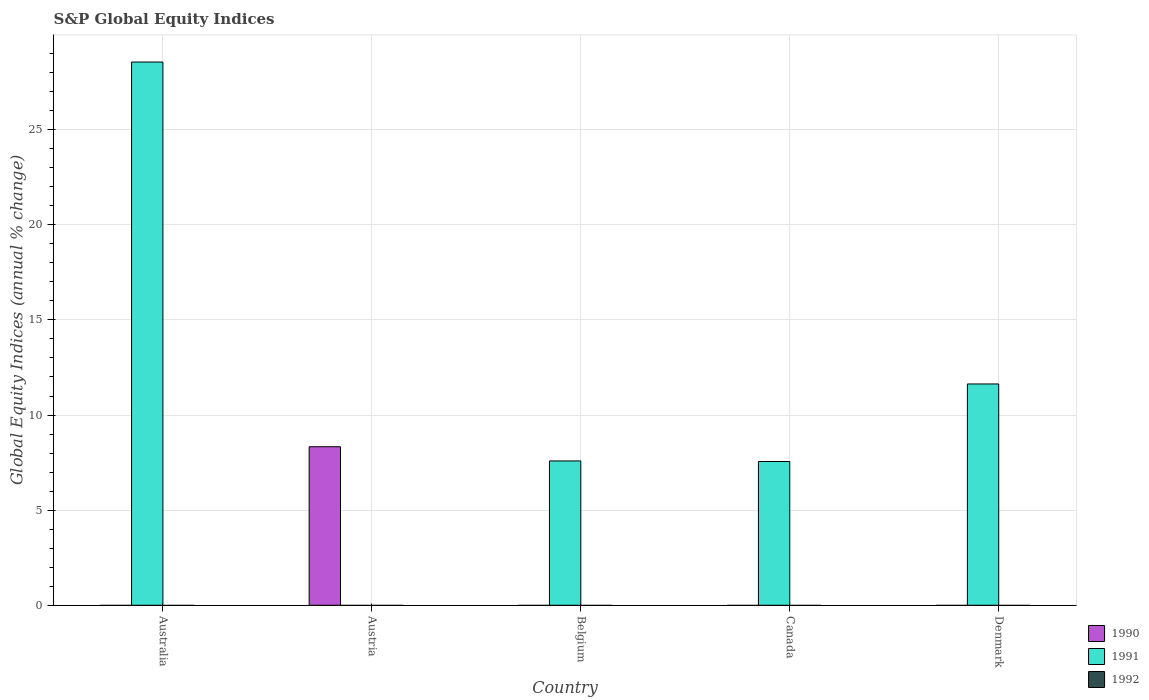How many bars are there on the 5th tick from the left?
Make the answer very short. 1. How many bars are there on the 2nd tick from the right?
Make the answer very short. 1. What is the global equity indices in 1990 in Canada?
Offer a terse response. 0. Across all countries, what is the maximum global equity indices in 1991?
Your response must be concise. 28.56. In which country was the global equity indices in 1990 maximum?
Offer a very short reply. Austria. What is the total global equity indices in 1990 in the graph?
Make the answer very short. 8.33. What is the difference between the global equity indices in 1991 in Canada and that in Denmark?
Your response must be concise. -4.08. What is the difference between the global equity indices in 1990 in Canada and the global equity indices in 1991 in Australia?
Your response must be concise. -28.56. What is the average global equity indices in 1991 per country?
Offer a very short reply. 11.07. What is the ratio of the global equity indices in 1991 in Australia to that in Belgium?
Keep it short and to the point. 3.76. Is the global equity indices in 1991 in Canada less than that in Denmark?
Offer a very short reply. Yes. What is the difference between the highest and the second highest global equity indices in 1991?
Your answer should be compact. -16.92. What is the difference between the highest and the lowest global equity indices in 1991?
Provide a short and direct response. 28.56. How many bars are there?
Keep it short and to the point. 5. How many countries are there in the graph?
Your answer should be very brief. 5. Are the values on the major ticks of Y-axis written in scientific E-notation?
Offer a very short reply. No. Does the graph contain any zero values?
Offer a terse response. Yes. Does the graph contain grids?
Offer a terse response. Yes. Where does the legend appear in the graph?
Provide a succinct answer. Bottom right. How many legend labels are there?
Give a very brief answer. 3. How are the legend labels stacked?
Your answer should be compact. Vertical. What is the title of the graph?
Keep it short and to the point. S&P Global Equity Indices. What is the label or title of the Y-axis?
Your answer should be very brief. Global Equity Indices (annual % change). What is the Global Equity Indices (annual % change) in 1991 in Australia?
Your answer should be compact. 28.56. What is the Global Equity Indices (annual % change) in 1990 in Austria?
Ensure brevity in your answer.  8.33. What is the Global Equity Indices (annual % change) in 1991 in Belgium?
Ensure brevity in your answer.  7.59. What is the Global Equity Indices (annual % change) in 1990 in Canada?
Offer a terse response. 0. What is the Global Equity Indices (annual % change) of 1991 in Canada?
Ensure brevity in your answer.  7.56. What is the Global Equity Indices (annual % change) in 1990 in Denmark?
Provide a short and direct response. 0. What is the Global Equity Indices (annual % change) in 1991 in Denmark?
Provide a short and direct response. 11.63. What is the Global Equity Indices (annual % change) in 1992 in Denmark?
Keep it short and to the point. 0. Across all countries, what is the maximum Global Equity Indices (annual % change) of 1990?
Offer a terse response. 8.33. Across all countries, what is the maximum Global Equity Indices (annual % change) in 1991?
Offer a terse response. 28.56. What is the total Global Equity Indices (annual % change) in 1990 in the graph?
Make the answer very short. 8.33. What is the total Global Equity Indices (annual % change) in 1991 in the graph?
Keep it short and to the point. 55.33. What is the difference between the Global Equity Indices (annual % change) of 1991 in Australia and that in Belgium?
Your answer should be compact. 20.97. What is the difference between the Global Equity Indices (annual % change) in 1991 in Australia and that in Canada?
Offer a terse response. 21. What is the difference between the Global Equity Indices (annual % change) in 1991 in Australia and that in Denmark?
Your answer should be very brief. 16.92. What is the difference between the Global Equity Indices (annual % change) of 1991 in Belgium and that in Canada?
Ensure brevity in your answer.  0.03. What is the difference between the Global Equity Indices (annual % change) of 1991 in Belgium and that in Denmark?
Keep it short and to the point. -4.05. What is the difference between the Global Equity Indices (annual % change) in 1991 in Canada and that in Denmark?
Provide a succinct answer. -4.08. What is the difference between the Global Equity Indices (annual % change) of 1990 in Austria and the Global Equity Indices (annual % change) of 1991 in Belgium?
Your answer should be very brief. 0.75. What is the difference between the Global Equity Indices (annual % change) of 1990 in Austria and the Global Equity Indices (annual % change) of 1991 in Canada?
Ensure brevity in your answer.  0.78. What is the difference between the Global Equity Indices (annual % change) of 1990 in Austria and the Global Equity Indices (annual % change) of 1991 in Denmark?
Your answer should be compact. -3.3. What is the average Global Equity Indices (annual % change) in 1990 per country?
Make the answer very short. 1.67. What is the average Global Equity Indices (annual % change) of 1991 per country?
Provide a short and direct response. 11.07. What is the ratio of the Global Equity Indices (annual % change) of 1991 in Australia to that in Belgium?
Your response must be concise. 3.76. What is the ratio of the Global Equity Indices (annual % change) of 1991 in Australia to that in Canada?
Provide a succinct answer. 3.78. What is the ratio of the Global Equity Indices (annual % change) of 1991 in Australia to that in Denmark?
Give a very brief answer. 2.45. What is the ratio of the Global Equity Indices (annual % change) in 1991 in Belgium to that in Canada?
Your answer should be very brief. 1. What is the ratio of the Global Equity Indices (annual % change) in 1991 in Belgium to that in Denmark?
Your answer should be compact. 0.65. What is the ratio of the Global Equity Indices (annual % change) of 1991 in Canada to that in Denmark?
Offer a very short reply. 0.65. What is the difference between the highest and the second highest Global Equity Indices (annual % change) of 1991?
Ensure brevity in your answer.  16.92. What is the difference between the highest and the lowest Global Equity Indices (annual % change) in 1990?
Give a very brief answer. 8.33. What is the difference between the highest and the lowest Global Equity Indices (annual % change) of 1991?
Keep it short and to the point. 28.56. 